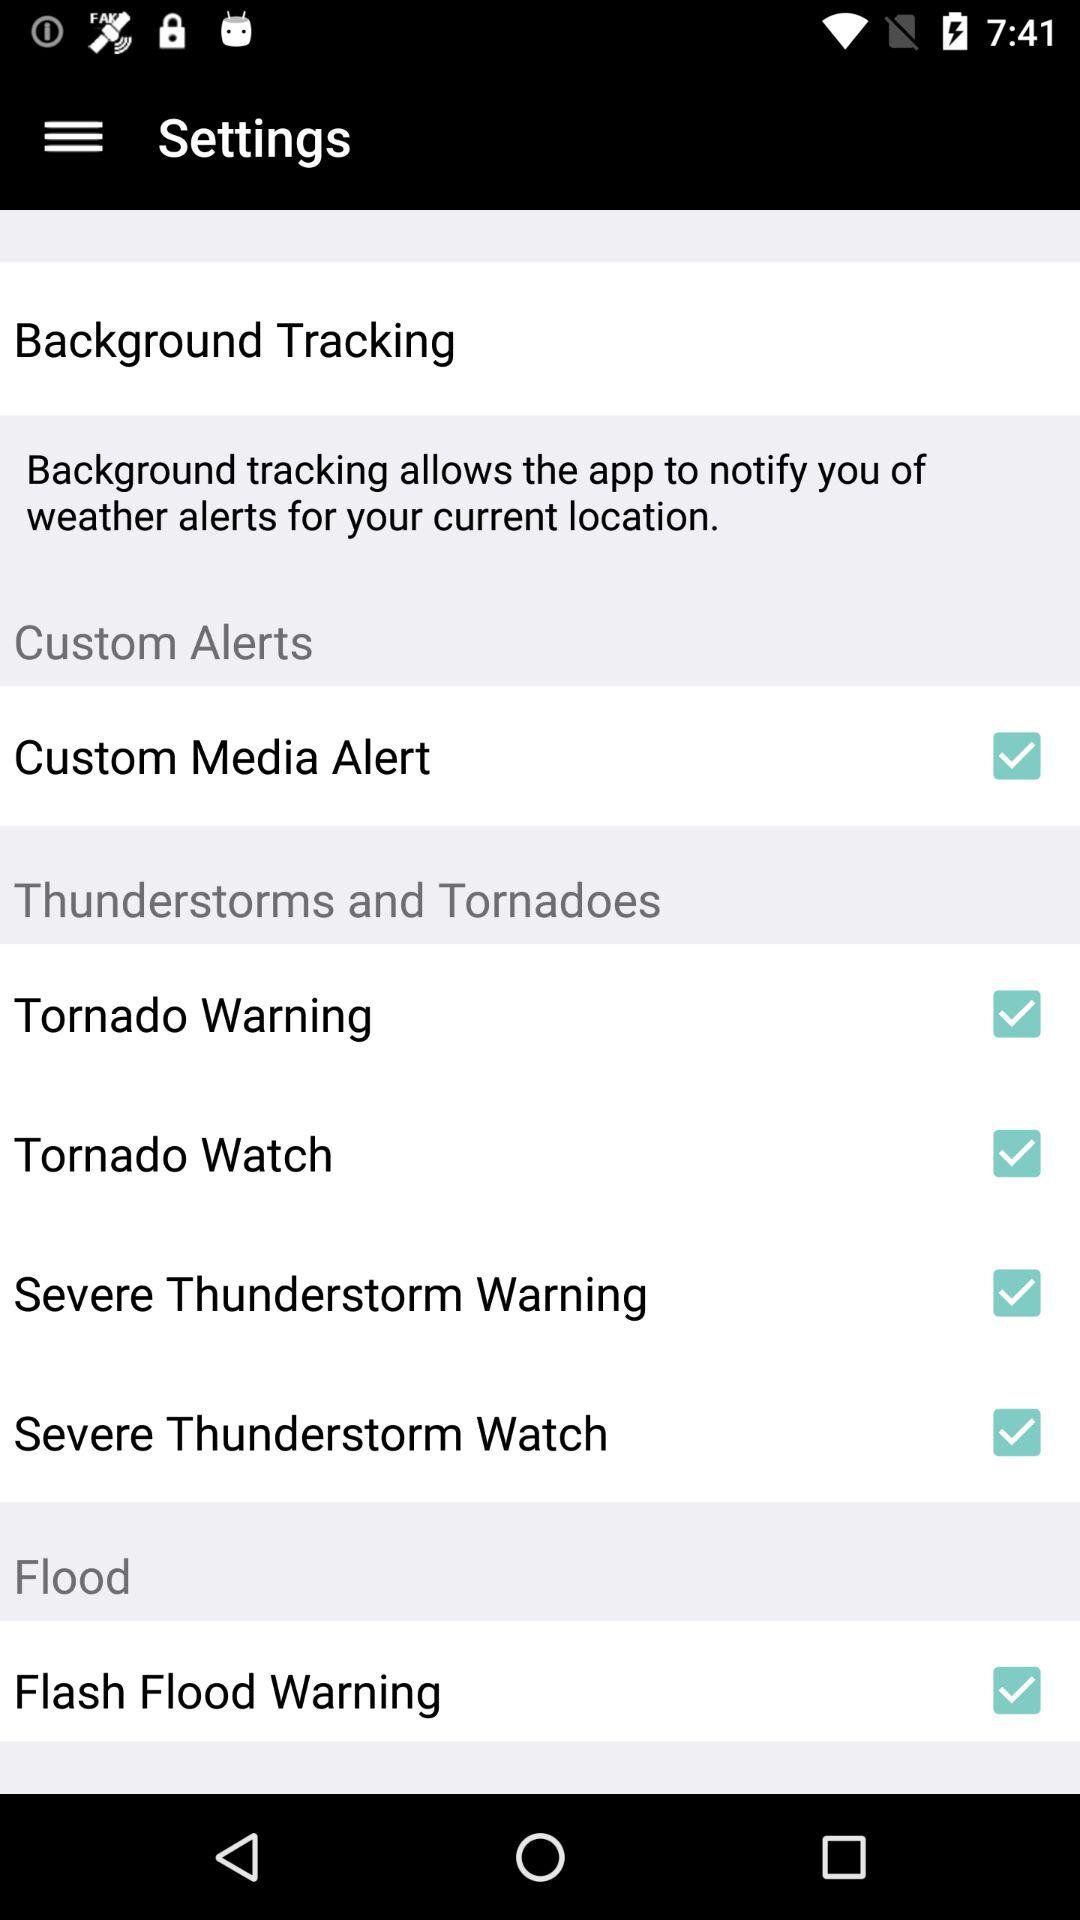What is the status of "Custom Media Alert"? The status is "on". 